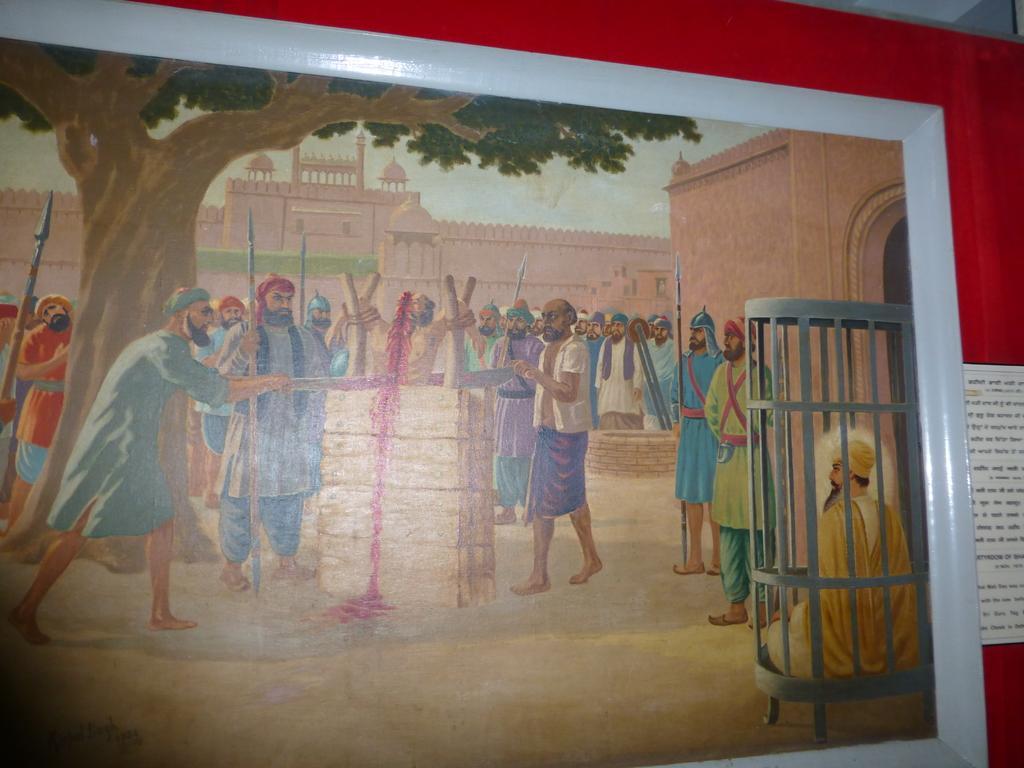How would you summarize this image in a sentence or two? In this image I can see a wall painting on a wall and there is a board on this wall with some text. 